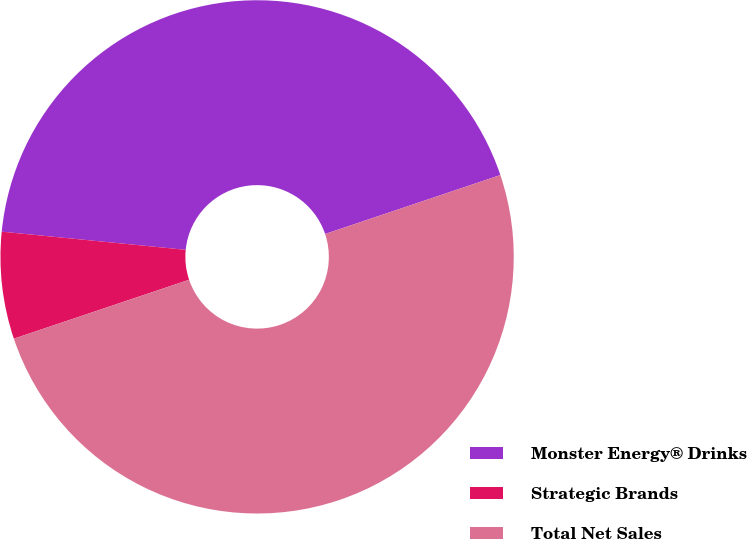Convert chart to OTSL. <chart><loc_0><loc_0><loc_500><loc_500><pie_chart><fcel>Monster Energy® Drinks<fcel>Strategic Brands<fcel>Total Net Sales<nl><fcel>43.27%<fcel>6.73%<fcel>50.0%<nl></chart> 